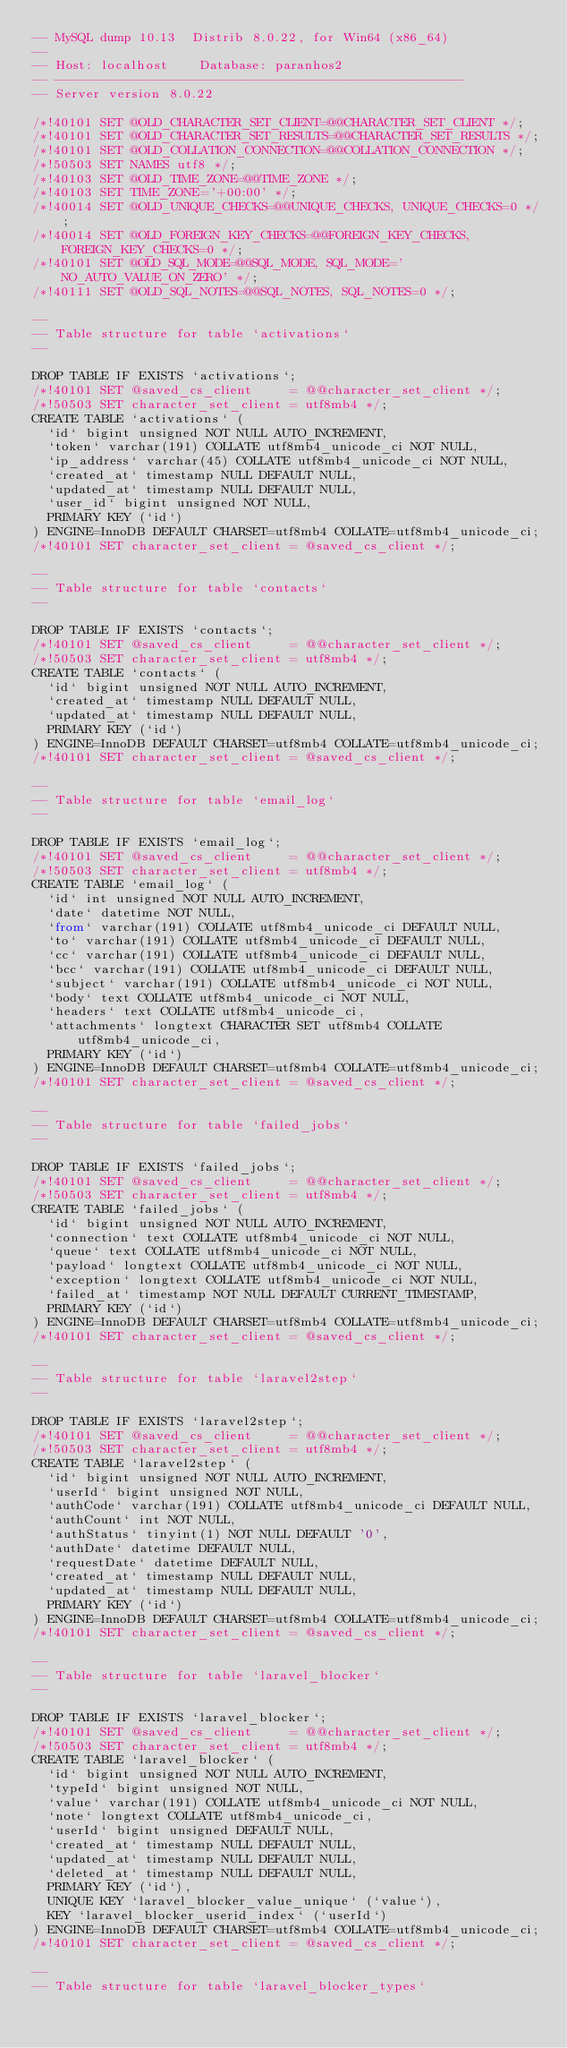<code> <loc_0><loc_0><loc_500><loc_500><_SQL_>-- MySQL dump 10.13  Distrib 8.0.22, for Win64 (x86_64)
--
-- Host: localhost    Database: paranhos2
-- ------------------------------------------------------
-- Server version	8.0.22

/*!40101 SET @OLD_CHARACTER_SET_CLIENT=@@CHARACTER_SET_CLIENT */;
/*!40101 SET @OLD_CHARACTER_SET_RESULTS=@@CHARACTER_SET_RESULTS */;
/*!40101 SET @OLD_COLLATION_CONNECTION=@@COLLATION_CONNECTION */;
/*!50503 SET NAMES utf8 */;
/*!40103 SET @OLD_TIME_ZONE=@@TIME_ZONE */;
/*!40103 SET TIME_ZONE='+00:00' */;
/*!40014 SET @OLD_UNIQUE_CHECKS=@@UNIQUE_CHECKS, UNIQUE_CHECKS=0 */;
/*!40014 SET @OLD_FOREIGN_KEY_CHECKS=@@FOREIGN_KEY_CHECKS, FOREIGN_KEY_CHECKS=0 */;
/*!40101 SET @OLD_SQL_MODE=@@SQL_MODE, SQL_MODE='NO_AUTO_VALUE_ON_ZERO' */;
/*!40111 SET @OLD_SQL_NOTES=@@SQL_NOTES, SQL_NOTES=0 */;

--
-- Table structure for table `activations`
--

DROP TABLE IF EXISTS `activations`;
/*!40101 SET @saved_cs_client     = @@character_set_client */;
/*!50503 SET character_set_client = utf8mb4 */;
CREATE TABLE `activations` (
  `id` bigint unsigned NOT NULL AUTO_INCREMENT,
  `token` varchar(191) COLLATE utf8mb4_unicode_ci NOT NULL,
  `ip_address` varchar(45) COLLATE utf8mb4_unicode_ci NOT NULL,
  `created_at` timestamp NULL DEFAULT NULL,
  `updated_at` timestamp NULL DEFAULT NULL,
  `user_id` bigint unsigned NOT NULL,
  PRIMARY KEY (`id`)
) ENGINE=InnoDB DEFAULT CHARSET=utf8mb4 COLLATE=utf8mb4_unicode_ci;
/*!40101 SET character_set_client = @saved_cs_client */;

--
-- Table structure for table `contacts`
--

DROP TABLE IF EXISTS `contacts`;
/*!40101 SET @saved_cs_client     = @@character_set_client */;
/*!50503 SET character_set_client = utf8mb4 */;
CREATE TABLE `contacts` (
  `id` bigint unsigned NOT NULL AUTO_INCREMENT,
  `created_at` timestamp NULL DEFAULT NULL,
  `updated_at` timestamp NULL DEFAULT NULL,
  PRIMARY KEY (`id`)
) ENGINE=InnoDB DEFAULT CHARSET=utf8mb4 COLLATE=utf8mb4_unicode_ci;
/*!40101 SET character_set_client = @saved_cs_client */;

--
-- Table structure for table `email_log`
--

DROP TABLE IF EXISTS `email_log`;
/*!40101 SET @saved_cs_client     = @@character_set_client */;
/*!50503 SET character_set_client = utf8mb4 */;
CREATE TABLE `email_log` (
  `id` int unsigned NOT NULL AUTO_INCREMENT,
  `date` datetime NOT NULL,
  `from` varchar(191) COLLATE utf8mb4_unicode_ci DEFAULT NULL,
  `to` varchar(191) COLLATE utf8mb4_unicode_ci DEFAULT NULL,
  `cc` varchar(191) COLLATE utf8mb4_unicode_ci DEFAULT NULL,
  `bcc` varchar(191) COLLATE utf8mb4_unicode_ci DEFAULT NULL,
  `subject` varchar(191) COLLATE utf8mb4_unicode_ci NOT NULL,
  `body` text COLLATE utf8mb4_unicode_ci NOT NULL,
  `headers` text COLLATE utf8mb4_unicode_ci,
  `attachments` longtext CHARACTER SET utf8mb4 COLLATE utf8mb4_unicode_ci,
  PRIMARY KEY (`id`)
) ENGINE=InnoDB DEFAULT CHARSET=utf8mb4 COLLATE=utf8mb4_unicode_ci;
/*!40101 SET character_set_client = @saved_cs_client */;

--
-- Table structure for table `failed_jobs`
--

DROP TABLE IF EXISTS `failed_jobs`;
/*!40101 SET @saved_cs_client     = @@character_set_client */;
/*!50503 SET character_set_client = utf8mb4 */;
CREATE TABLE `failed_jobs` (
  `id` bigint unsigned NOT NULL AUTO_INCREMENT,
  `connection` text COLLATE utf8mb4_unicode_ci NOT NULL,
  `queue` text COLLATE utf8mb4_unicode_ci NOT NULL,
  `payload` longtext COLLATE utf8mb4_unicode_ci NOT NULL,
  `exception` longtext COLLATE utf8mb4_unicode_ci NOT NULL,
  `failed_at` timestamp NOT NULL DEFAULT CURRENT_TIMESTAMP,
  PRIMARY KEY (`id`)
) ENGINE=InnoDB DEFAULT CHARSET=utf8mb4 COLLATE=utf8mb4_unicode_ci;
/*!40101 SET character_set_client = @saved_cs_client */;

--
-- Table structure for table `laravel2step`
--

DROP TABLE IF EXISTS `laravel2step`;
/*!40101 SET @saved_cs_client     = @@character_set_client */;
/*!50503 SET character_set_client = utf8mb4 */;
CREATE TABLE `laravel2step` (
  `id` bigint unsigned NOT NULL AUTO_INCREMENT,
  `userId` bigint unsigned NOT NULL,
  `authCode` varchar(191) COLLATE utf8mb4_unicode_ci DEFAULT NULL,
  `authCount` int NOT NULL,
  `authStatus` tinyint(1) NOT NULL DEFAULT '0',
  `authDate` datetime DEFAULT NULL,
  `requestDate` datetime DEFAULT NULL,
  `created_at` timestamp NULL DEFAULT NULL,
  `updated_at` timestamp NULL DEFAULT NULL,
  PRIMARY KEY (`id`)
) ENGINE=InnoDB DEFAULT CHARSET=utf8mb4 COLLATE=utf8mb4_unicode_ci;
/*!40101 SET character_set_client = @saved_cs_client */;

--
-- Table structure for table `laravel_blocker`
--

DROP TABLE IF EXISTS `laravel_blocker`;
/*!40101 SET @saved_cs_client     = @@character_set_client */;
/*!50503 SET character_set_client = utf8mb4 */;
CREATE TABLE `laravel_blocker` (
  `id` bigint unsigned NOT NULL AUTO_INCREMENT,
  `typeId` bigint unsigned NOT NULL,
  `value` varchar(191) COLLATE utf8mb4_unicode_ci NOT NULL,
  `note` longtext COLLATE utf8mb4_unicode_ci,
  `userId` bigint unsigned DEFAULT NULL,
  `created_at` timestamp NULL DEFAULT NULL,
  `updated_at` timestamp NULL DEFAULT NULL,
  `deleted_at` timestamp NULL DEFAULT NULL,
  PRIMARY KEY (`id`),
  UNIQUE KEY `laravel_blocker_value_unique` (`value`),
  KEY `laravel_blocker_userid_index` (`userId`)
) ENGINE=InnoDB DEFAULT CHARSET=utf8mb4 COLLATE=utf8mb4_unicode_ci;
/*!40101 SET character_set_client = @saved_cs_client */;

--
-- Table structure for table `laravel_blocker_types`</code> 